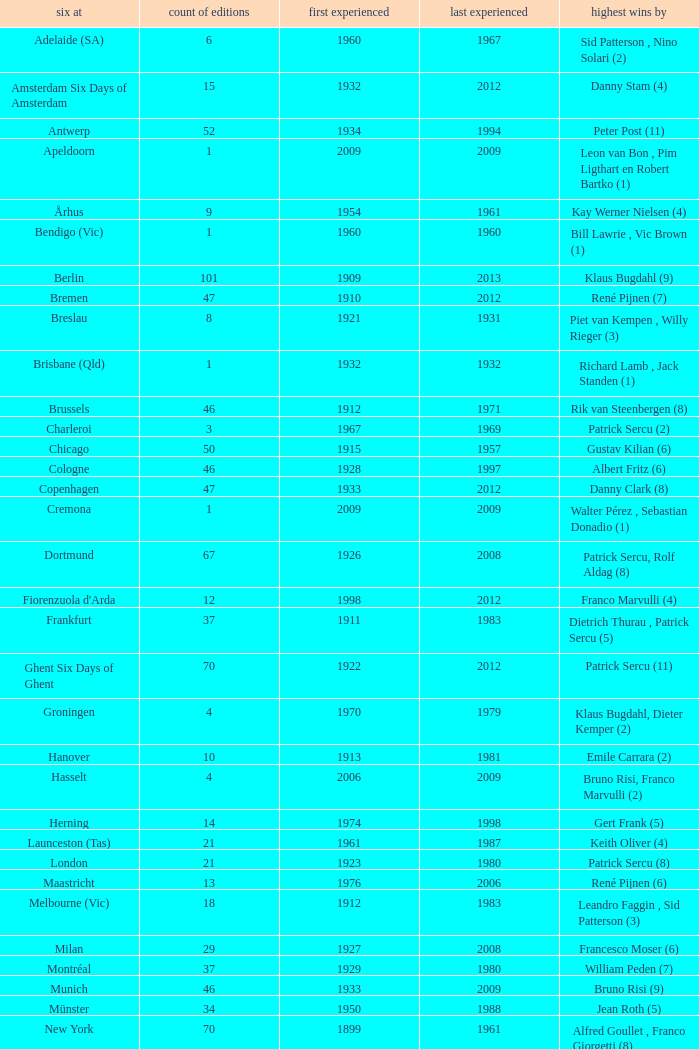How many editions have a most wins value of Franco Marvulli (4)? 1.0. 